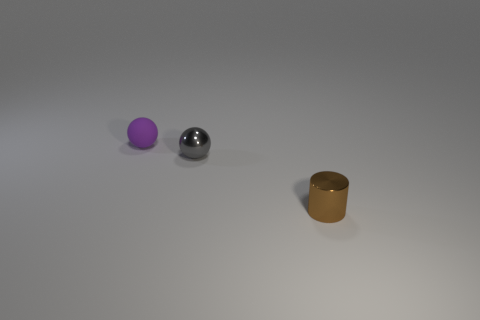How many objects are behind the brown thing and in front of the purple ball?
Offer a terse response. 1. The rubber object that is the same shape as the small gray metal object is what color?
Offer a terse response. Purple. Are there fewer large brown rubber blocks than metallic cylinders?
Give a very brief answer. Yes. Do the gray shiny thing and the metallic thing in front of the gray shiny object have the same size?
Provide a succinct answer. Yes. What color is the ball that is behind the small sphere that is on the right side of the rubber thing?
Ensure brevity in your answer.  Purple. What number of objects are metallic things that are behind the small cylinder or tiny metallic cylinders that are in front of the rubber object?
Keep it short and to the point. 2. Is the purple sphere the same size as the brown shiny object?
Your answer should be compact. Yes. Are there any other things that have the same size as the brown cylinder?
Keep it short and to the point. Yes. There is a tiny object to the right of the gray thing; is its shape the same as the metal object that is on the left side of the tiny cylinder?
Give a very brief answer. No. What size is the gray object?
Your response must be concise. Small. 